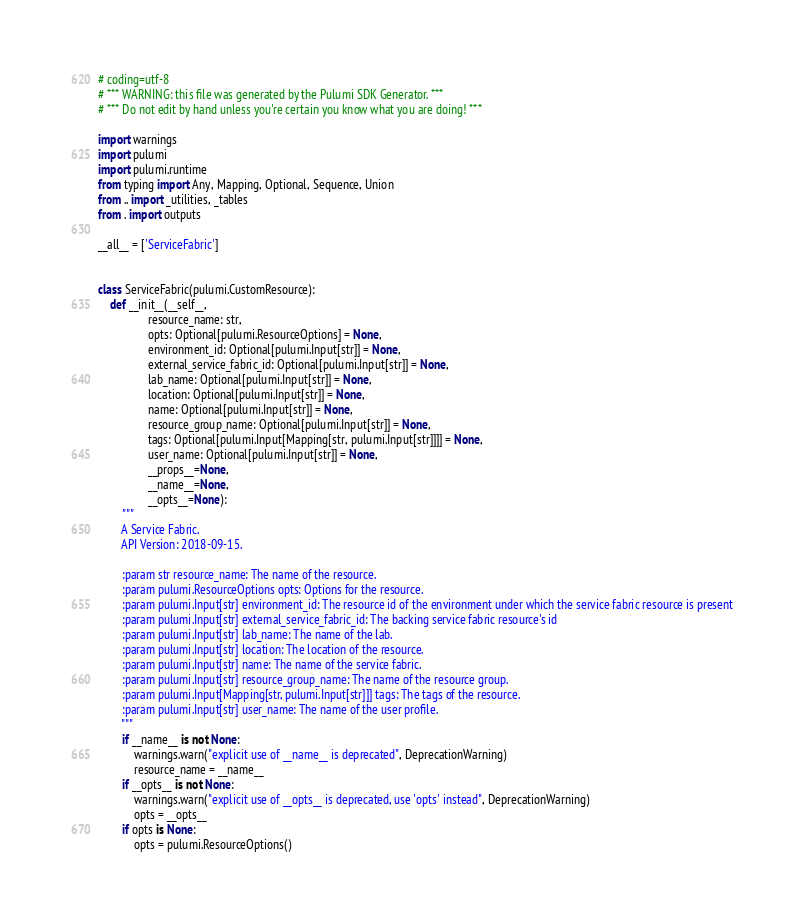<code> <loc_0><loc_0><loc_500><loc_500><_Python_># coding=utf-8
# *** WARNING: this file was generated by the Pulumi SDK Generator. ***
# *** Do not edit by hand unless you're certain you know what you are doing! ***

import warnings
import pulumi
import pulumi.runtime
from typing import Any, Mapping, Optional, Sequence, Union
from .. import _utilities, _tables
from . import outputs

__all__ = ['ServiceFabric']


class ServiceFabric(pulumi.CustomResource):
    def __init__(__self__,
                 resource_name: str,
                 opts: Optional[pulumi.ResourceOptions] = None,
                 environment_id: Optional[pulumi.Input[str]] = None,
                 external_service_fabric_id: Optional[pulumi.Input[str]] = None,
                 lab_name: Optional[pulumi.Input[str]] = None,
                 location: Optional[pulumi.Input[str]] = None,
                 name: Optional[pulumi.Input[str]] = None,
                 resource_group_name: Optional[pulumi.Input[str]] = None,
                 tags: Optional[pulumi.Input[Mapping[str, pulumi.Input[str]]]] = None,
                 user_name: Optional[pulumi.Input[str]] = None,
                 __props__=None,
                 __name__=None,
                 __opts__=None):
        """
        A Service Fabric.
        API Version: 2018-09-15.

        :param str resource_name: The name of the resource.
        :param pulumi.ResourceOptions opts: Options for the resource.
        :param pulumi.Input[str] environment_id: The resource id of the environment under which the service fabric resource is present
        :param pulumi.Input[str] external_service_fabric_id: The backing service fabric resource's id
        :param pulumi.Input[str] lab_name: The name of the lab.
        :param pulumi.Input[str] location: The location of the resource.
        :param pulumi.Input[str] name: The name of the service fabric.
        :param pulumi.Input[str] resource_group_name: The name of the resource group.
        :param pulumi.Input[Mapping[str, pulumi.Input[str]]] tags: The tags of the resource.
        :param pulumi.Input[str] user_name: The name of the user profile.
        """
        if __name__ is not None:
            warnings.warn("explicit use of __name__ is deprecated", DeprecationWarning)
            resource_name = __name__
        if __opts__ is not None:
            warnings.warn("explicit use of __opts__ is deprecated, use 'opts' instead", DeprecationWarning)
            opts = __opts__
        if opts is None:
            opts = pulumi.ResourceOptions()</code> 